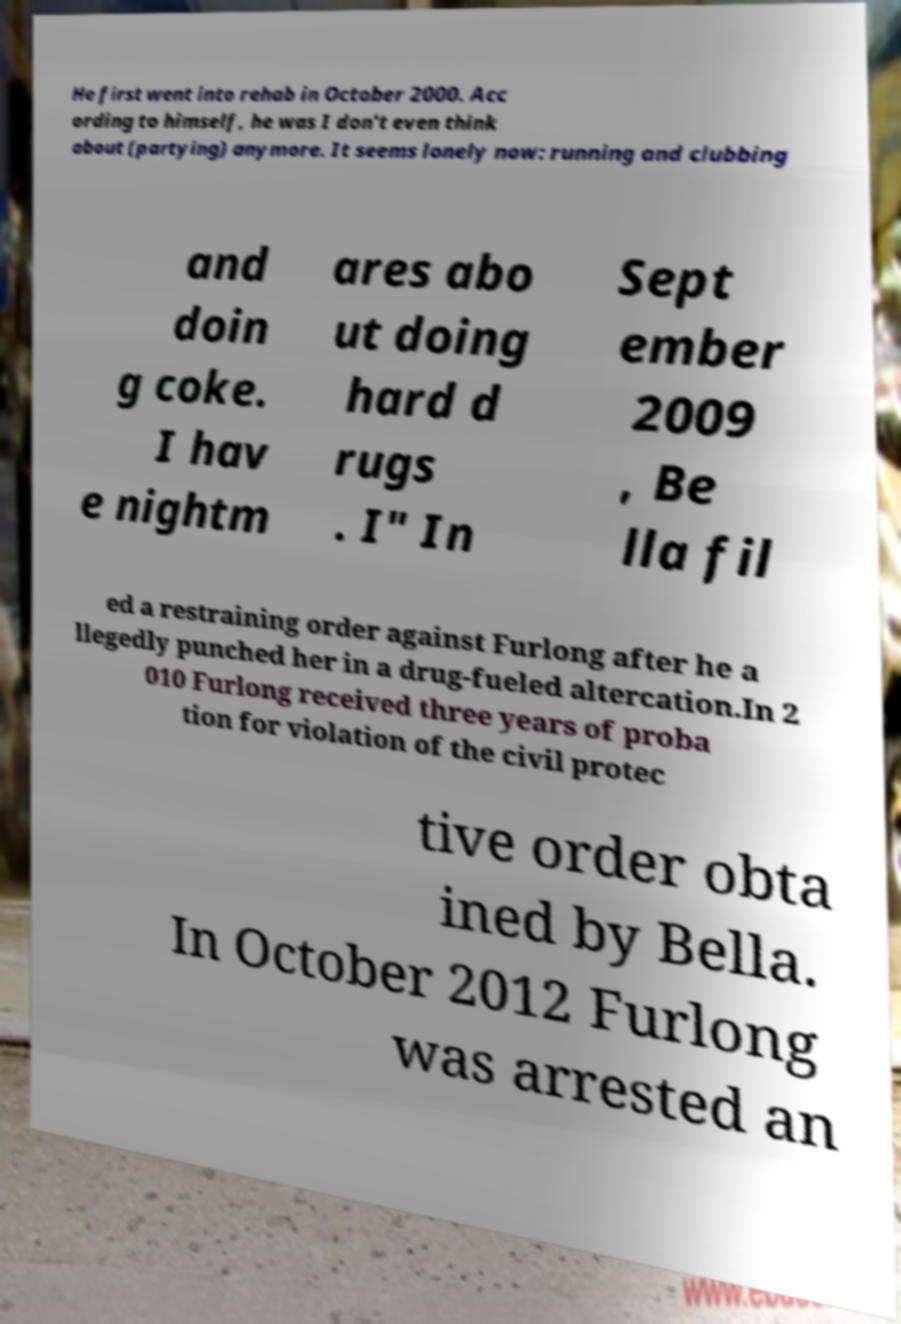For documentation purposes, I need the text within this image transcribed. Could you provide that? He first went into rehab in October 2000. Acc ording to himself, he was I don't even think about (partying) anymore. It seems lonely now: running and clubbing and doin g coke. I hav e nightm ares abo ut doing hard d rugs . I" In Sept ember 2009 , Be lla fil ed a restraining order against Furlong after he a llegedly punched her in a drug-fueled altercation.In 2 010 Furlong received three years of proba tion for violation of the civil protec tive order obta ined by Bella. In October 2012 Furlong was arrested an 